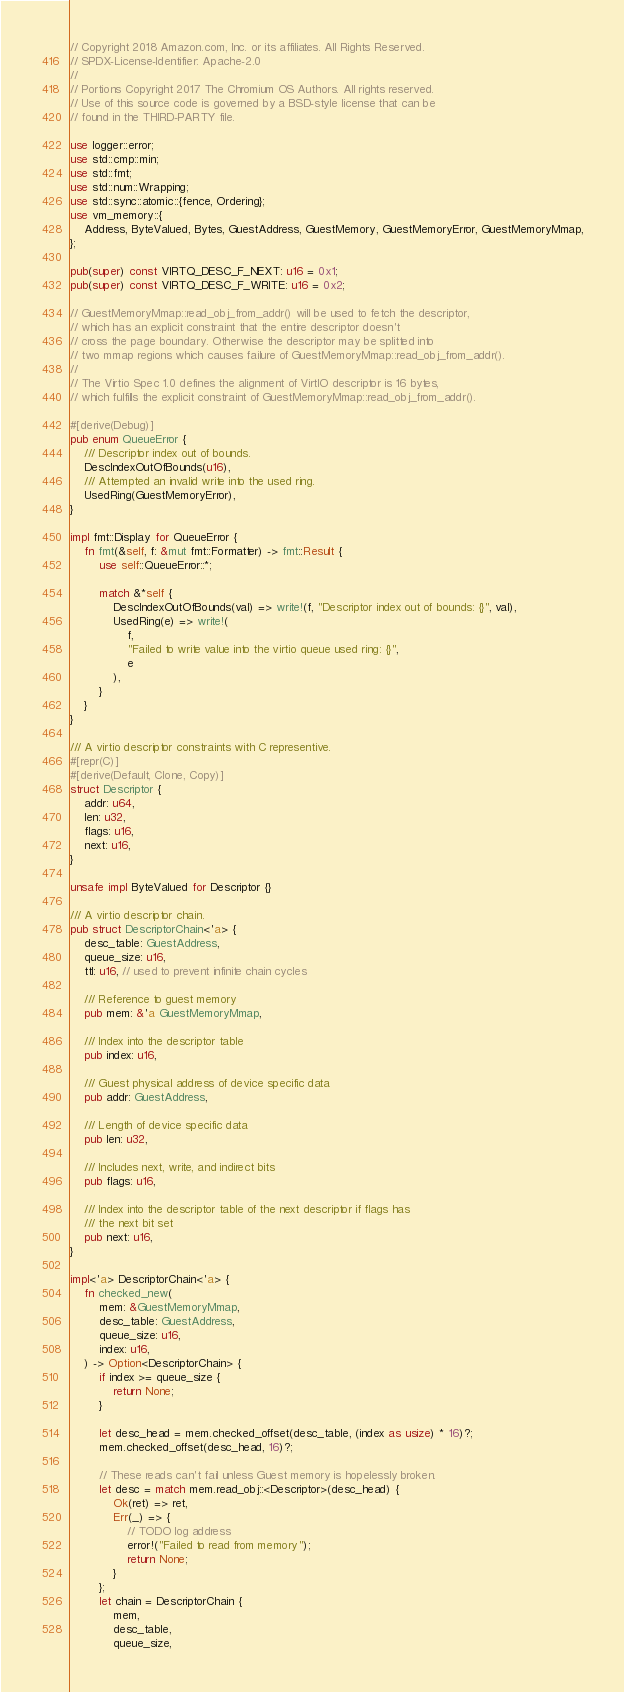<code> <loc_0><loc_0><loc_500><loc_500><_Rust_>// Copyright 2018 Amazon.com, Inc. or its affiliates. All Rights Reserved.
// SPDX-License-Identifier: Apache-2.0
//
// Portions Copyright 2017 The Chromium OS Authors. All rights reserved.
// Use of this source code is governed by a BSD-style license that can be
// found in the THIRD-PARTY file.

use logger::error;
use std::cmp::min;
use std::fmt;
use std::num::Wrapping;
use std::sync::atomic::{fence, Ordering};
use vm_memory::{
    Address, ByteValued, Bytes, GuestAddress, GuestMemory, GuestMemoryError, GuestMemoryMmap,
};

pub(super) const VIRTQ_DESC_F_NEXT: u16 = 0x1;
pub(super) const VIRTQ_DESC_F_WRITE: u16 = 0x2;

// GuestMemoryMmap::read_obj_from_addr() will be used to fetch the descriptor,
// which has an explicit constraint that the entire descriptor doesn't
// cross the page boundary. Otherwise the descriptor may be splitted into
// two mmap regions which causes failure of GuestMemoryMmap::read_obj_from_addr().
//
// The Virtio Spec 1.0 defines the alignment of VirtIO descriptor is 16 bytes,
// which fulfills the explicit constraint of GuestMemoryMmap::read_obj_from_addr().

#[derive(Debug)]
pub enum QueueError {
    /// Descriptor index out of bounds.
    DescIndexOutOfBounds(u16),
    /// Attempted an invalid write into the used ring.
    UsedRing(GuestMemoryError),
}

impl fmt::Display for QueueError {
    fn fmt(&self, f: &mut fmt::Formatter) -> fmt::Result {
        use self::QueueError::*;

        match &*self {
            DescIndexOutOfBounds(val) => write!(f, "Descriptor index out of bounds: {}", val),
            UsedRing(e) => write!(
                f,
                "Failed to write value into the virtio queue used ring: {}",
                e
            ),
        }
    }
}

/// A virtio descriptor constraints with C representive.
#[repr(C)]
#[derive(Default, Clone, Copy)]
struct Descriptor {
    addr: u64,
    len: u32,
    flags: u16,
    next: u16,
}

unsafe impl ByteValued for Descriptor {}

/// A virtio descriptor chain.
pub struct DescriptorChain<'a> {
    desc_table: GuestAddress,
    queue_size: u16,
    ttl: u16, // used to prevent infinite chain cycles

    /// Reference to guest memory
    pub mem: &'a GuestMemoryMmap,

    /// Index into the descriptor table
    pub index: u16,

    /// Guest physical address of device specific data
    pub addr: GuestAddress,

    /// Length of device specific data
    pub len: u32,

    /// Includes next, write, and indirect bits
    pub flags: u16,

    /// Index into the descriptor table of the next descriptor if flags has
    /// the next bit set
    pub next: u16,
}

impl<'a> DescriptorChain<'a> {
    fn checked_new(
        mem: &GuestMemoryMmap,
        desc_table: GuestAddress,
        queue_size: u16,
        index: u16,
    ) -> Option<DescriptorChain> {
        if index >= queue_size {
            return None;
        }

        let desc_head = mem.checked_offset(desc_table, (index as usize) * 16)?;
        mem.checked_offset(desc_head, 16)?;

        // These reads can't fail unless Guest memory is hopelessly broken.
        let desc = match mem.read_obj::<Descriptor>(desc_head) {
            Ok(ret) => ret,
            Err(_) => {
                // TODO log address
                error!("Failed to read from memory");
                return None;
            }
        };
        let chain = DescriptorChain {
            mem,
            desc_table,
            queue_size,</code> 